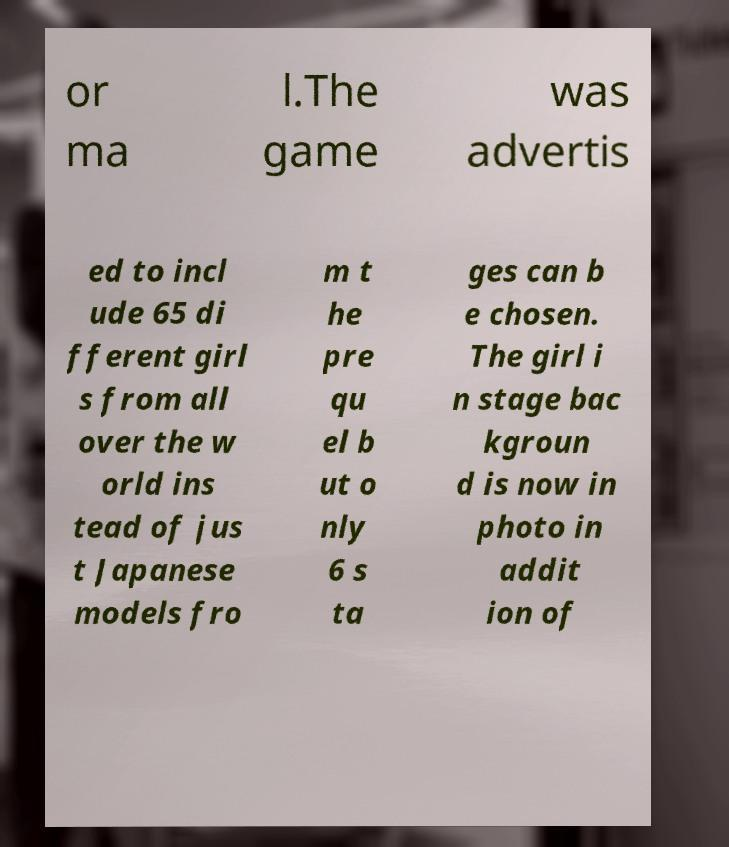Can you read and provide the text displayed in the image?This photo seems to have some interesting text. Can you extract and type it out for me? or ma l.The game was advertis ed to incl ude 65 di fferent girl s from all over the w orld ins tead of jus t Japanese models fro m t he pre qu el b ut o nly 6 s ta ges can b e chosen. The girl i n stage bac kgroun d is now in photo in addit ion of 